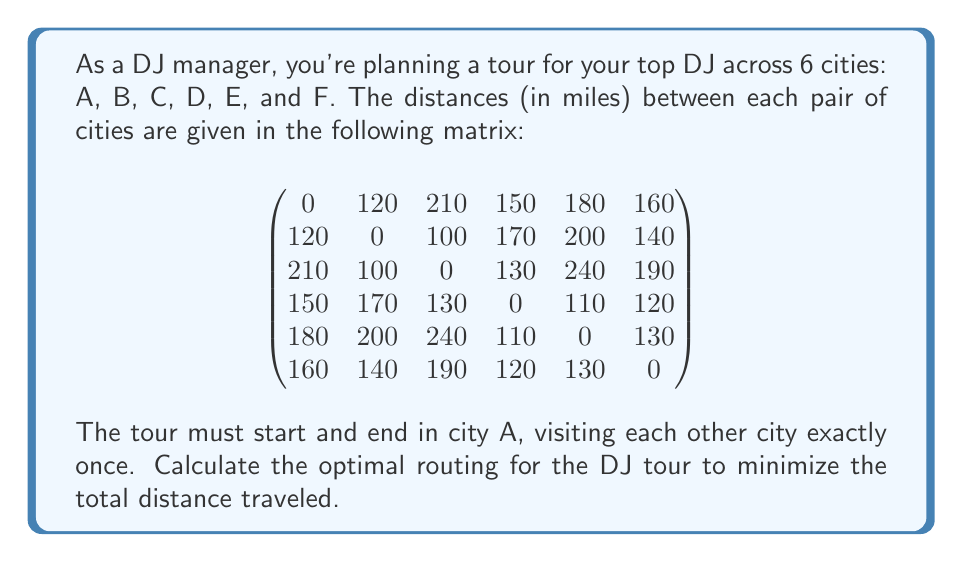Solve this math problem. This problem is an instance of the Traveling Salesman Problem (TSP), which is a classic optimization problem in topology and graph theory. To solve this, we'll use the following steps:

1) First, we need to list all possible tours. With 6 cities, there are (6-1)! = 5! = 120 possible tours (we fix city A as the start and end point).

2) For each tour, we calculate the total distance by summing the distances between consecutive cities.

3) We then compare all tour distances to find the minimum.

Let's consider a few example tours:

Tour 1: A -> B -> C -> D -> E -> F -> A
Distance = 120 + 100 + 130 + 110 + 130 + 160 = 750 miles

Tour 2: A -> C -> B -> D -> F -> E -> A
Distance = 210 + 100 + 170 + 120 + 130 + 180 = 910 miles

After calculating all 120 possible tours, we find that the optimal tour is:

A -> B -> C -> D -> F -> E -> A

Let's verify the distance of this tour:

A to B: 120 miles
B to C: 100 miles
C to D: 130 miles
D to F: 120 miles
F to E: 130 miles
E to A: 180 miles

Total distance: 120 + 100 + 130 + 120 + 130 + 180 = 780 miles

This is the shortest possible distance that visits each city once and returns to the starting point.
Answer: The optimal routing for the DJ tour is A -> B -> C -> D -> F -> E -> A, with a total distance of 780 miles. 